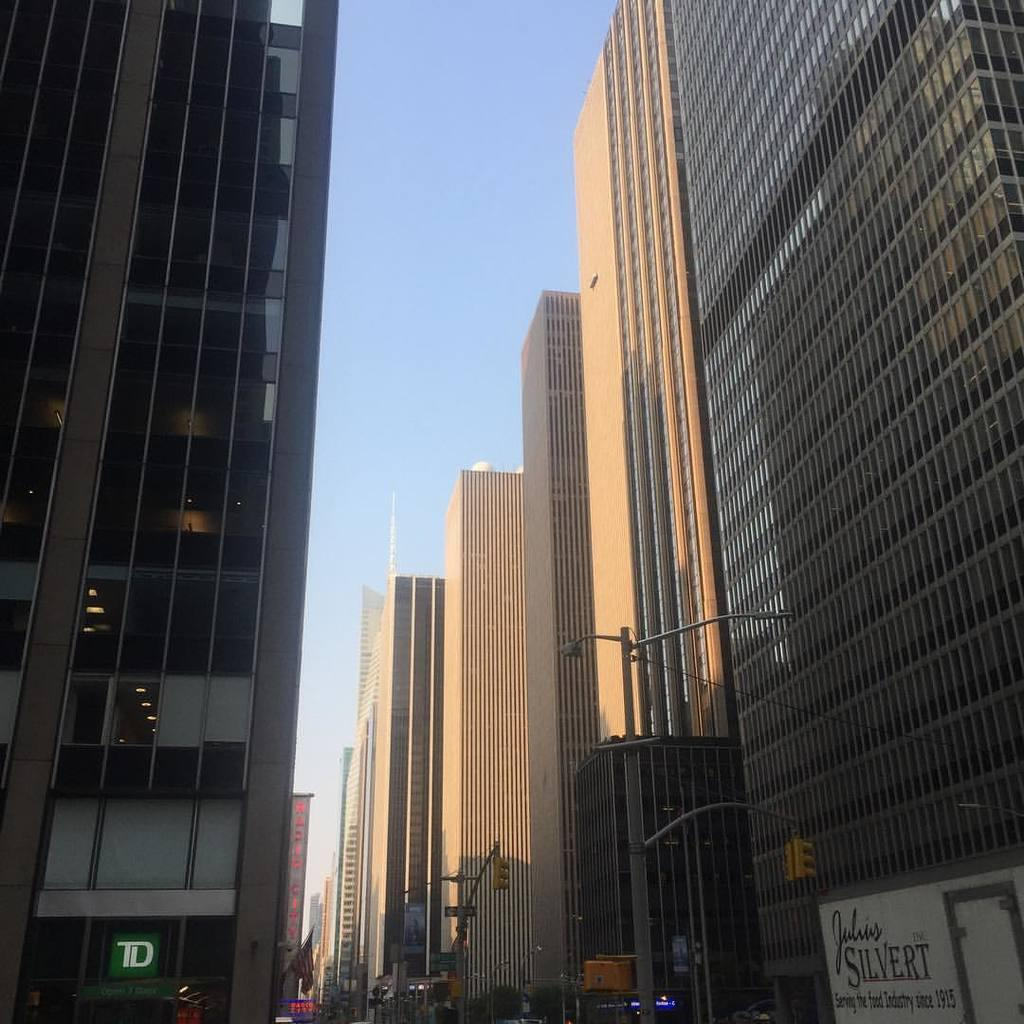What type of signaling device is present in the image? There are traffic lights in the image. How are the traffic lights positioned in the image? The traffic lights are attached to a pole. What can be seen on either side of the traffic lights? There are buildings on either side of the traffic lights. Is there a writer sitting at a desk in the image? There is no writer or desk present in the image; it features traffic lights and buildings. 